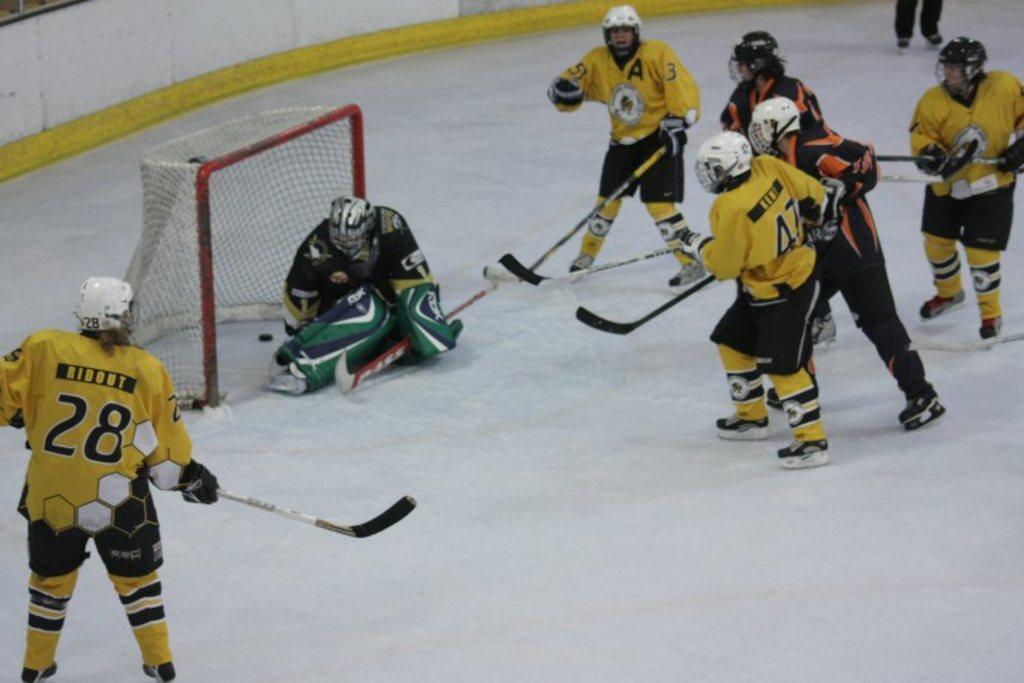Can you describe this image briefly? In this given image, We can see a couple of players, Who is playing a game including goalkeeper. 